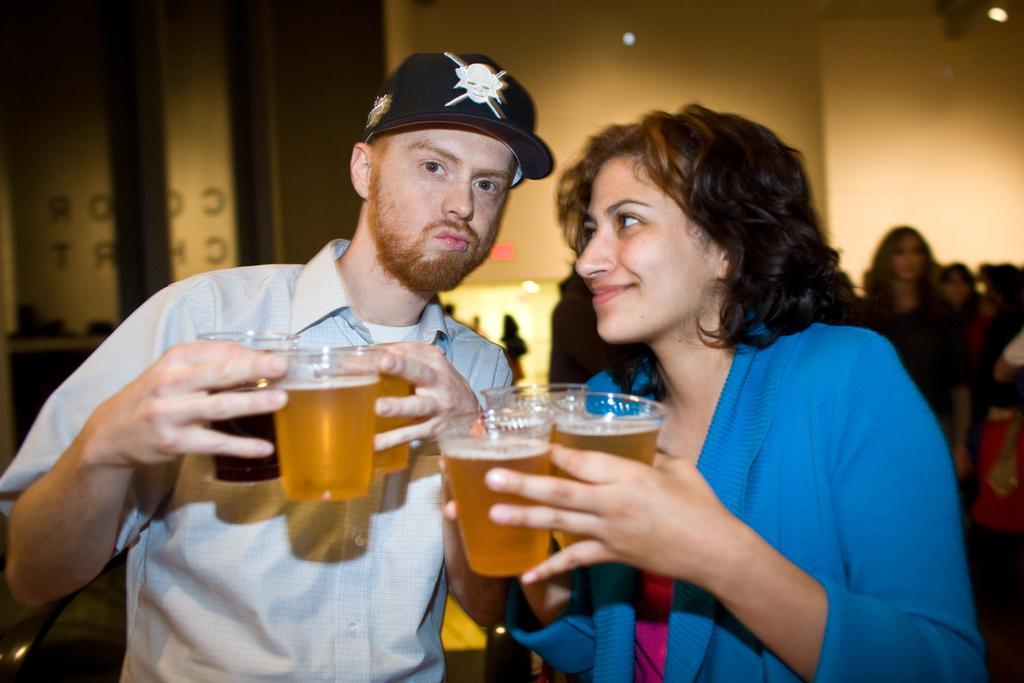Describe this image in one or two sentences. In this image I can see the women and man standing. They are holding beer glasses in their hands. At background I can see few people standing. 